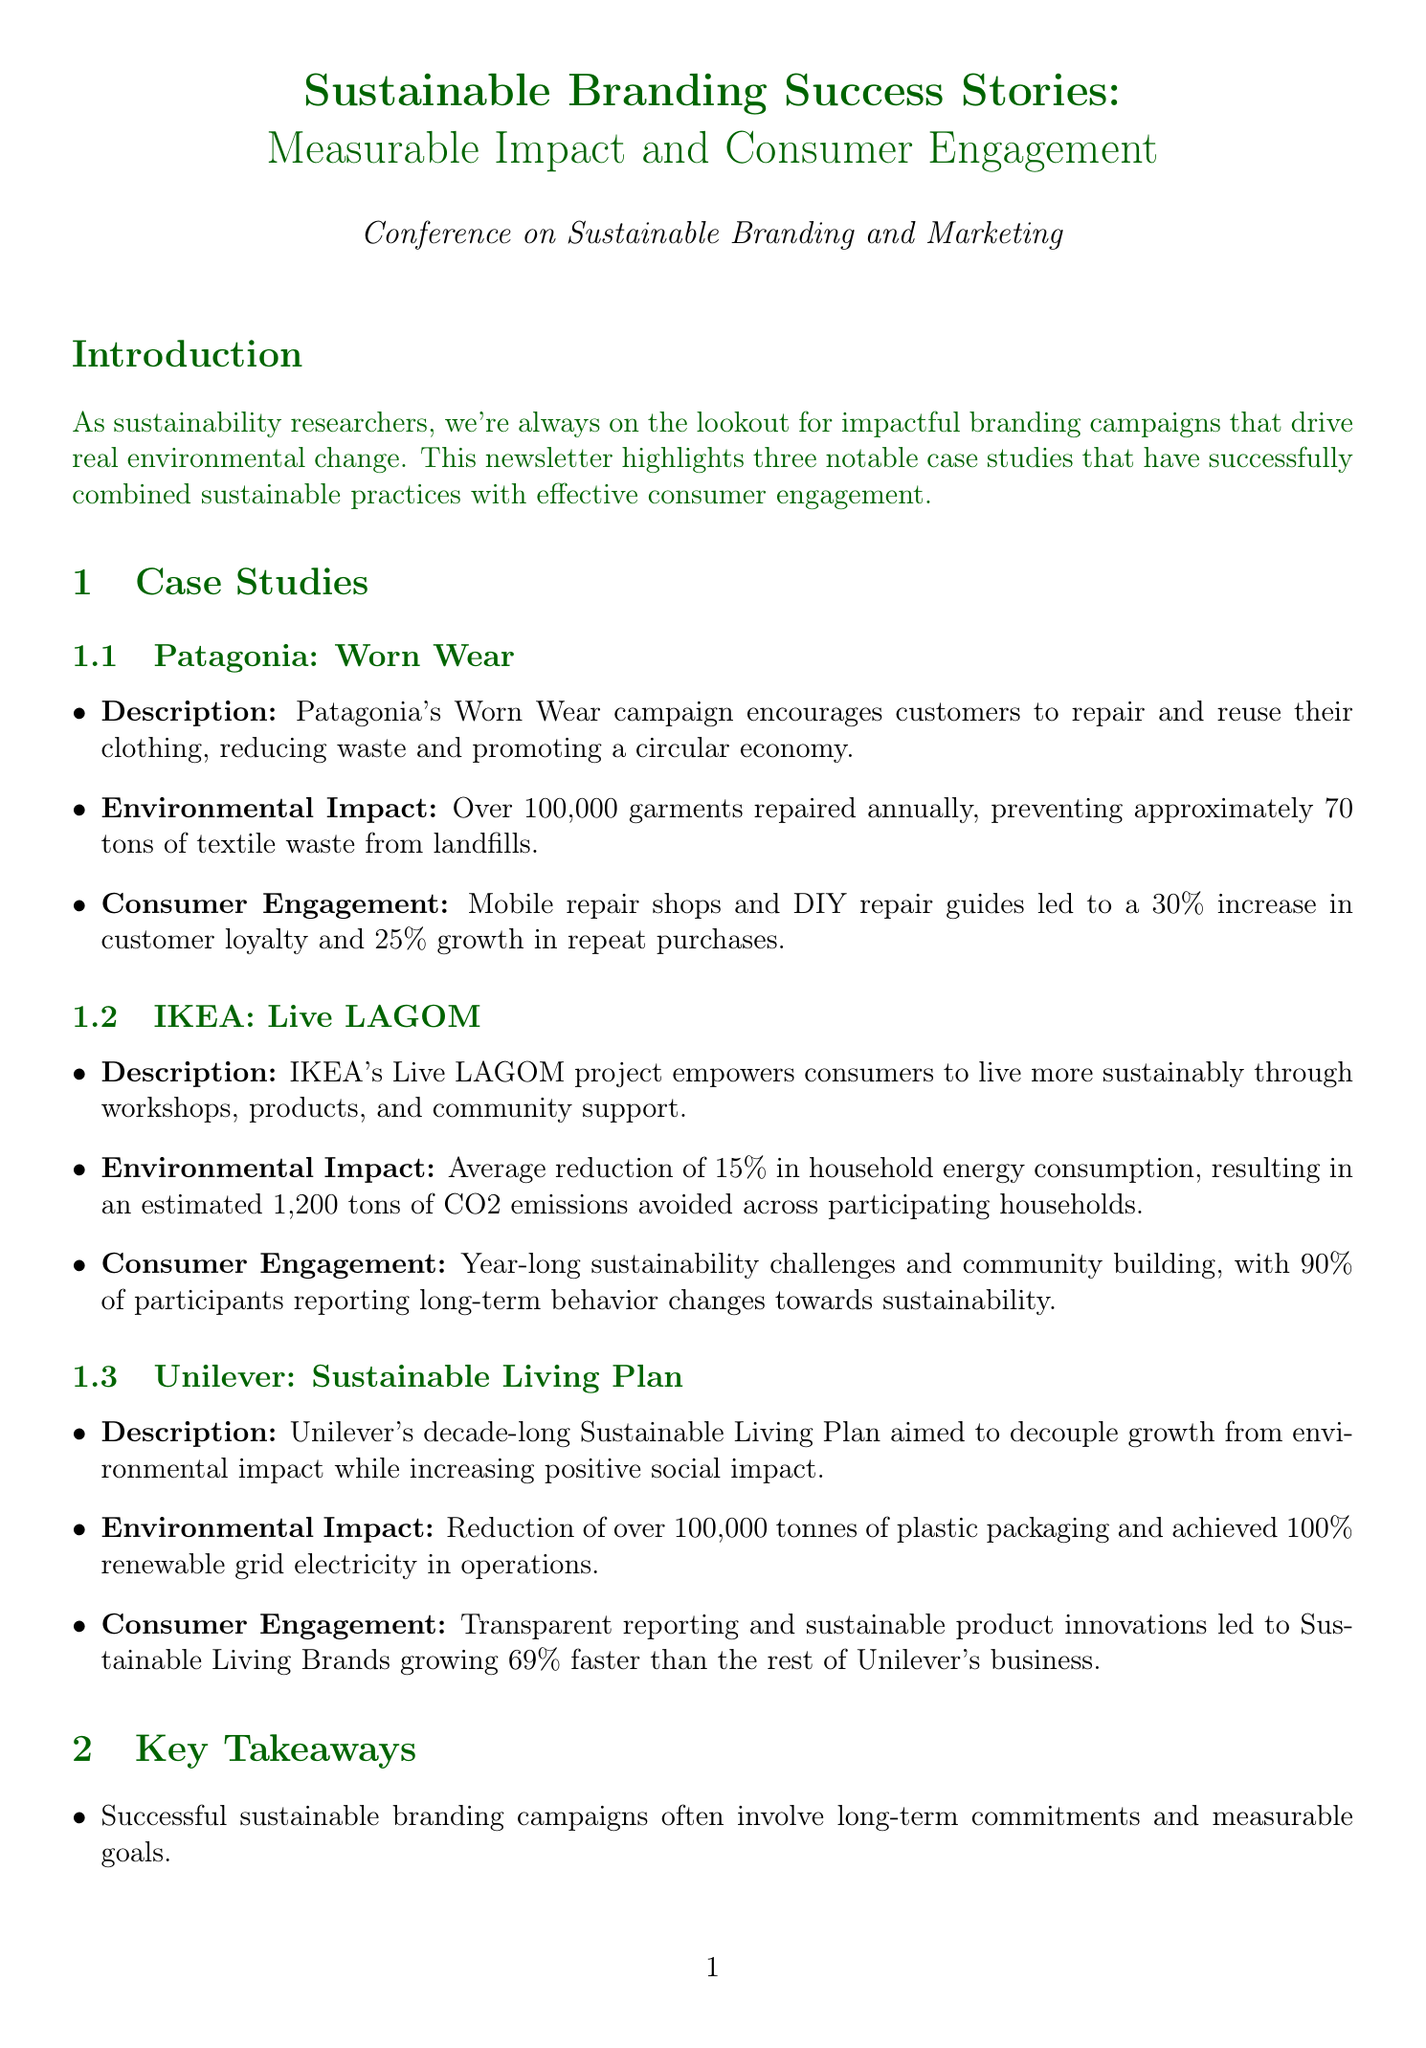What is the title of the newsletter? The title of the newsletter is presented at the beginning of the document.
Answer: Sustainable Branding Success Stories: Measurable Impact and Consumer Engagement How many garments does Patagonia repair annually? The document specifies this number in the environmental impact section for Patagonia's campaign.
Answer: Over 100,000 annually What percentage of participants in IKEA's Live LAGOM project reported long-term behavior changes? This information can be found in the consumer engagement section for IKEA's campaign.
Answer: 90% What was the estimated CO2 emissions avoided in IKEA's campaign? The document states this result in the environmental impact section for IKEA's campaign.
Answer: 1,200 tons Which company reduced plastic packaging by over 100,000 tonnes? The document identifies this company in the environmental impact section of Unilever's campaign.
Answer: Unilever What consumer engagement strategy did Patagonia use? This strategy is described in the consumer engagement section of Patagonia's case study.
Answer: Mobile repair shops and DIY repair guides Which key takeaway emphasizes the importance of transparency? The key takeaways section outlines various important points regarding sustainable branding.
Answer: Transparency in reporting environmental impacts builds trust and reinforces brand loyalty What is the name of the campaign by Unilever mentioned in the document? The campaign name is discussed in the case study section for Unilever.
Answer: Sustainable Living Plan 